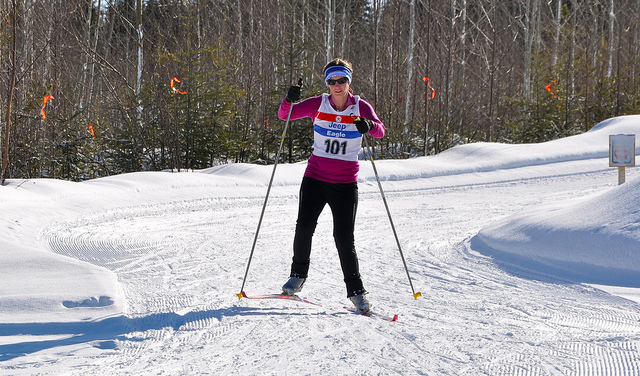Identify the text contained in this image. Jeep 101 